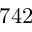<formula> <loc_0><loc_0><loc_500><loc_500>7 4 2</formula> 